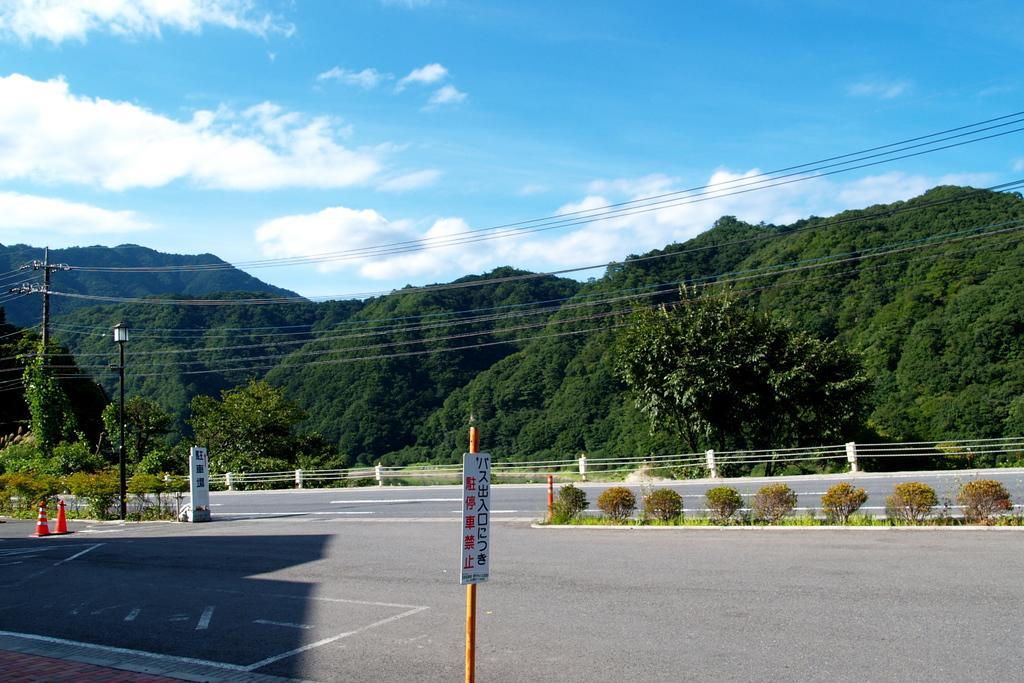How would you summarize this image in a sentence or two? As we can see in the image there is a sign board, traffic cones, plants, trees, hills, street lamp, current pole, sky and clouds. 